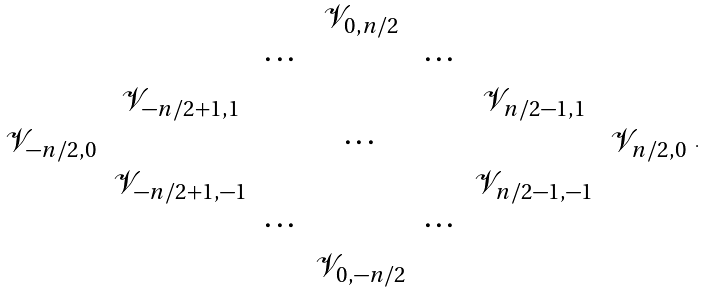Convert formula to latex. <formula><loc_0><loc_0><loc_500><loc_500>\begin{array} { c c c c c c c } & & & \mathcal { V } _ { 0 , n / 2 } & & & \\ & & \cdots & & \cdots & & \\ & \mathcal { V } _ { - n / 2 + 1 , 1 } & & & & \mathcal { V } _ { n / 2 - 1 , 1 } & \\ \mathcal { V } _ { - n / 2 , 0 } & & & \cdots & & & \mathcal { V } _ { n / 2 , 0 } \\ & \mathcal { V } _ { - n / 2 + 1 , - 1 } & & & & \mathcal { V } _ { n / 2 - 1 , - 1 } & \\ & & \cdots & & \cdots & & \\ & & & \mathcal { V } _ { 0 , - n / 2 } & & & \\ \end{array} .</formula> 